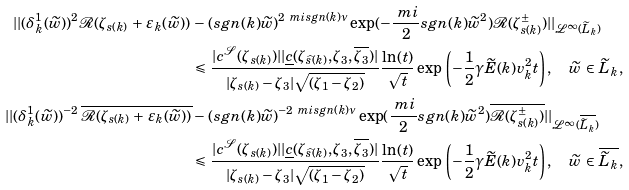<formula> <loc_0><loc_0><loc_500><loc_500>| | ( \delta _ { k } ^ { 1 } ( \widetilde { w } ) ) ^ { 2 } \mathcal { R } ( \zeta _ { s ( k ) } \, + \, \varepsilon _ { k } ( \widetilde { w } ) ) \, & - \, ( s g n ( k ) \widetilde { w } ) ^ { 2 \ m i s g n ( k ) \nu } \exp ( - \frac { \ m i } { 2 } s g n ( k ) \widetilde { w } ^ { 2 } ) \mathcal { R } ( \zeta _ { s ( k ) } ^ { \pm } ) | | _ { \mathcal { L } ^ { \infty } ( \widetilde { L } _ { k } ) } \\ & \leqslant \, \frac { | c ^ { \mathcal { S } } ( \zeta _ { s ( k ) } ) | | \underline { c } ( \zeta _ { \widehat { s } ( k ) } , \zeta _ { 3 } , \overline { \zeta _ { 3 } } ) | } { | \zeta _ { s ( k ) } - \zeta _ { 3 } | \sqrt { ( \zeta _ { 1 } - \zeta _ { 2 } ) } } \frac { \ln ( t ) } { \sqrt { t } } \exp \, \left ( - \frac { 1 } { 2 } \gamma \widetilde { E } ( k ) v _ { k } ^ { 2 } t \right ) , \quad \widetilde { w } \, \in \, \widetilde { L } _ { k } , \\ | | ( \delta _ { k } ^ { 1 } ( \widetilde { w } ) ) ^ { - 2 } \, \overline { \mathcal { R } ( \zeta _ { s ( k ) } \, + \, \varepsilon _ { k } ( \widetilde { w } ) ) } & - \, ( s g n ( k ) \widetilde { w } ) ^ { - 2 \ m i s g n ( k ) \nu } \exp ( \frac { \ m i } { 2 } s g n ( k ) \widetilde { w } ^ { 2 } ) \overline { \mathcal { R } ( \zeta _ { s ( k ) } ^ { \pm } ) } | | _ { \mathcal { L } ^ { \infty } ( \overline { \widetilde { L } _ { k } } ) } \\ & \leqslant \, \frac { | c ^ { \mathcal { S } } ( \zeta _ { s ( k ) } ) | | \underline { c } ( \zeta _ { \widehat { s } ( k ) } , \zeta _ { 3 } , \overline { \zeta _ { 3 } } ) | } { | \zeta _ { s ( k ) } - \zeta _ { 3 } | \sqrt { ( \zeta _ { 1 } - \zeta _ { 2 } ) } } \frac { \ln ( t ) } { \sqrt { t } } \exp \, \left ( - \frac { 1 } { 2 } \gamma \widetilde { E } ( k ) v _ { k } ^ { 2 } t \right ) , \quad \widetilde { w } \, \in \, \overline { \widetilde { L } _ { k } } ,</formula> 